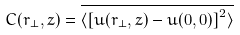<formula> <loc_0><loc_0><loc_500><loc_500>C ( { r } _ { \perp } , z ) = \overline { \langle \left [ u ( { r _ { \perp } } , z ) - u ( { 0 } , 0 ) \right ] ^ { 2 } \rangle } \,</formula> 